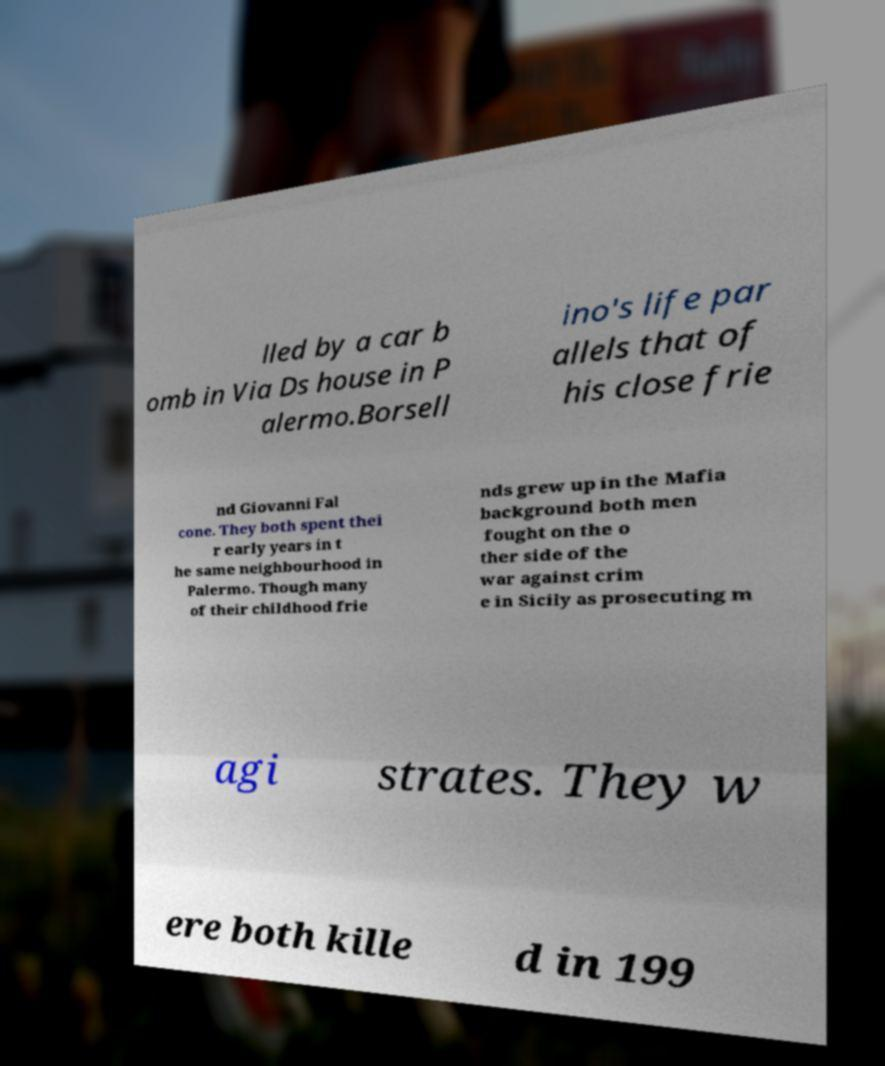Please read and relay the text visible in this image. What does it say? lled by a car b omb in Via Ds house in P alermo.Borsell ino's life par allels that of his close frie nd Giovanni Fal cone. They both spent thei r early years in t he same neighbourhood in Palermo. Though many of their childhood frie nds grew up in the Mafia background both men fought on the o ther side of the war against crim e in Sicily as prosecuting m agi strates. They w ere both kille d in 199 